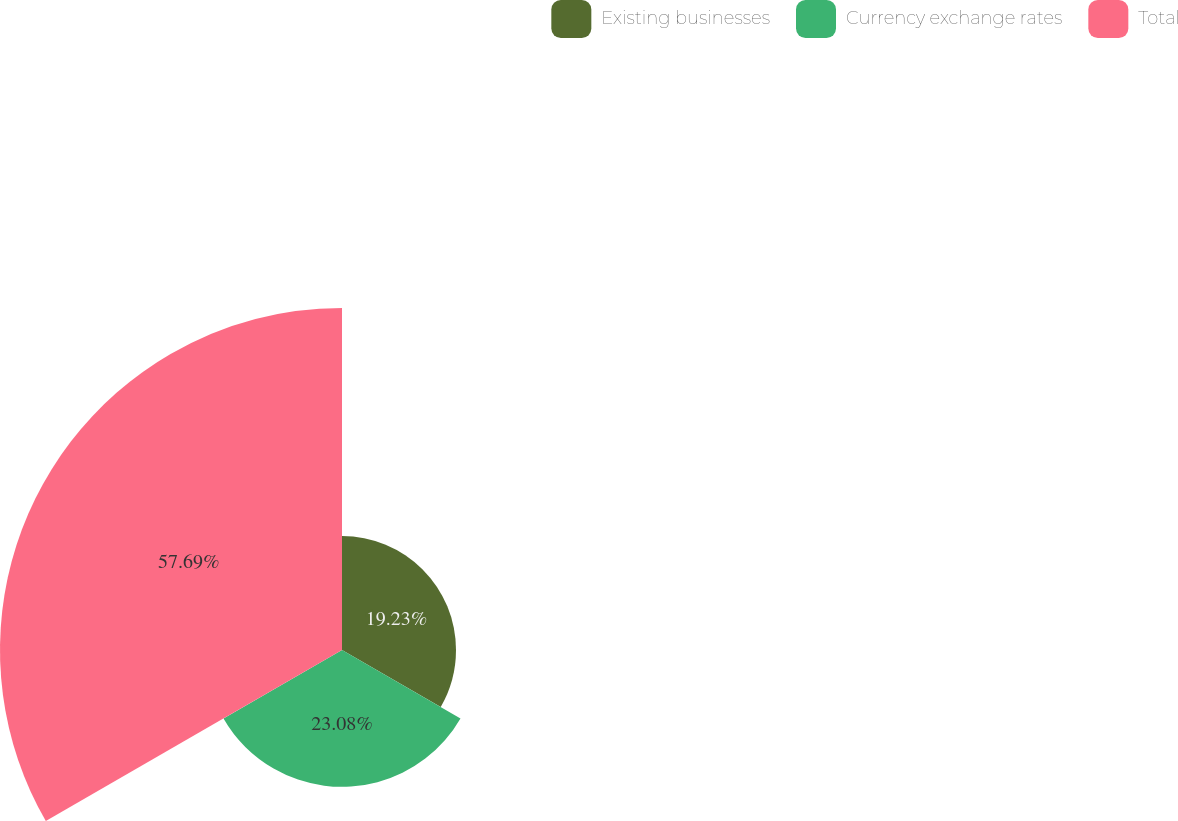<chart> <loc_0><loc_0><loc_500><loc_500><pie_chart><fcel>Existing businesses<fcel>Currency exchange rates<fcel>Total<nl><fcel>19.23%<fcel>23.08%<fcel>57.69%<nl></chart> 